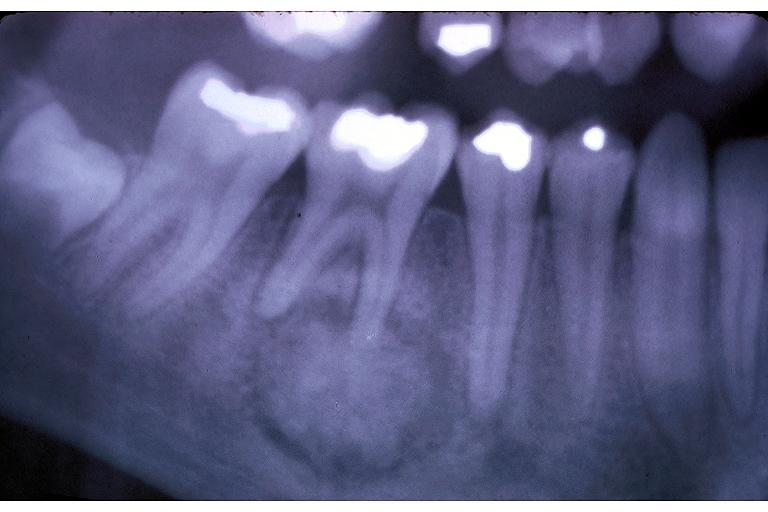does opened base of skull with brain show cementoblastoma?
Answer the question using a single word or phrase. No 